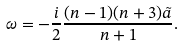Convert formula to latex. <formula><loc_0><loc_0><loc_500><loc_500>\omega = - \frac { i } { 2 } \frac { ( n - 1 ) ( n + 3 ) \tilde { a } } { n + 1 } .</formula> 